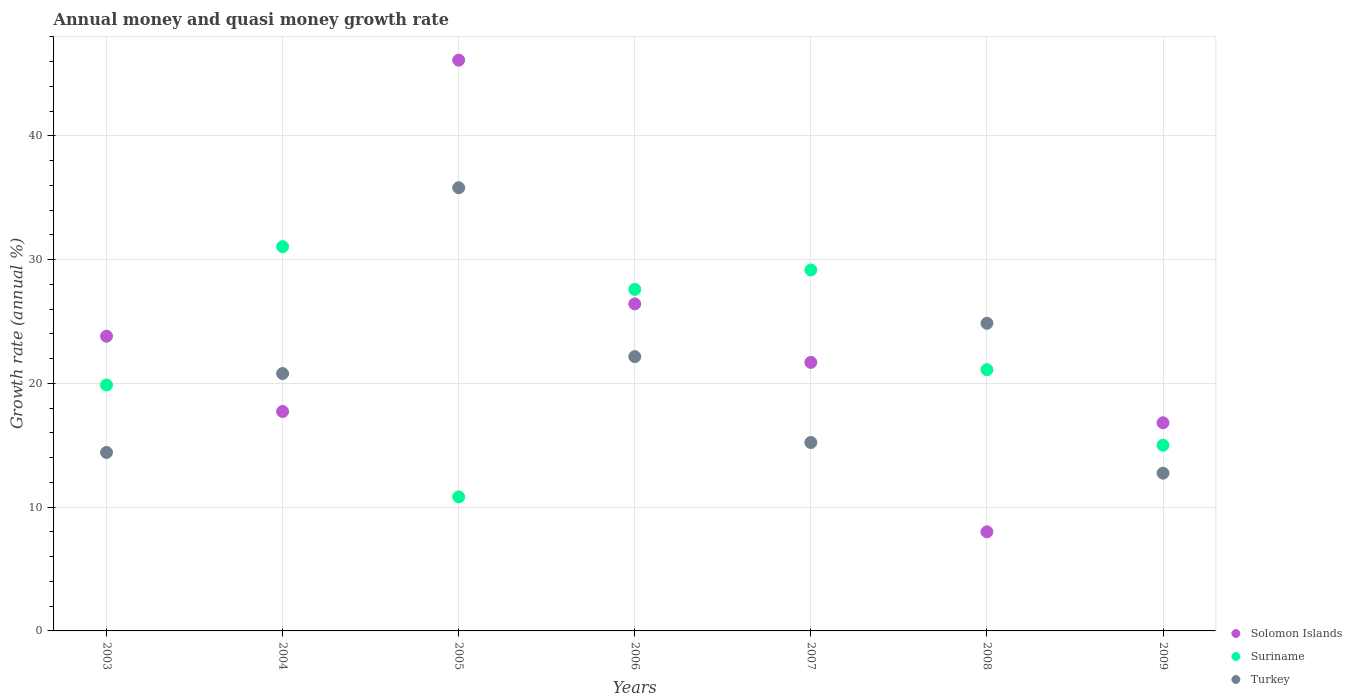How many different coloured dotlines are there?
Provide a succinct answer. 3. Is the number of dotlines equal to the number of legend labels?
Make the answer very short. Yes. What is the growth rate in Turkey in 2004?
Give a very brief answer. 20.8. Across all years, what is the maximum growth rate in Solomon Islands?
Offer a very short reply. 46.12. Across all years, what is the minimum growth rate in Turkey?
Provide a short and direct response. 12.75. In which year was the growth rate in Turkey maximum?
Give a very brief answer. 2005. In which year was the growth rate in Suriname minimum?
Your response must be concise. 2005. What is the total growth rate in Solomon Islands in the graph?
Your response must be concise. 160.61. What is the difference between the growth rate in Solomon Islands in 2006 and that in 2009?
Offer a terse response. 9.6. What is the difference between the growth rate in Solomon Islands in 2006 and the growth rate in Turkey in 2007?
Your answer should be compact. 11.2. What is the average growth rate in Solomon Islands per year?
Offer a very short reply. 22.94. In the year 2007, what is the difference between the growth rate in Suriname and growth rate in Solomon Islands?
Your response must be concise. 7.47. What is the ratio of the growth rate in Turkey in 2004 to that in 2008?
Provide a short and direct response. 0.84. Is the growth rate in Turkey in 2004 less than that in 2008?
Provide a short and direct response. Yes. What is the difference between the highest and the second highest growth rate in Suriname?
Make the answer very short. 1.89. What is the difference between the highest and the lowest growth rate in Solomon Islands?
Your answer should be compact. 38.11. Does the growth rate in Turkey monotonically increase over the years?
Your answer should be compact. No. Is the growth rate in Suriname strictly greater than the growth rate in Turkey over the years?
Offer a terse response. No. Is the growth rate in Solomon Islands strictly less than the growth rate in Turkey over the years?
Your answer should be compact. No. Are the values on the major ticks of Y-axis written in scientific E-notation?
Your response must be concise. No. Does the graph contain any zero values?
Your response must be concise. No. How many legend labels are there?
Your response must be concise. 3. How are the legend labels stacked?
Offer a very short reply. Vertical. What is the title of the graph?
Your response must be concise. Annual money and quasi money growth rate. What is the label or title of the Y-axis?
Your response must be concise. Growth rate (annual %). What is the Growth rate (annual %) of Solomon Islands in 2003?
Your answer should be very brief. 23.82. What is the Growth rate (annual %) of Suriname in 2003?
Make the answer very short. 19.87. What is the Growth rate (annual %) in Turkey in 2003?
Ensure brevity in your answer.  14.42. What is the Growth rate (annual %) of Solomon Islands in 2004?
Make the answer very short. 17.73. What is the Growth rate (annual %) in Suriname in 2004?
Give a very brief answer. 31.05. What is the Growth rate (annual %) in Turkey in 2004?
Your response must be concise. 20.8. What is the Growth rate (annual %) of Solomon Islands in 2005?
Keep it short and to the point. 46.12. What is the Growth rate (annual %) of Suriname in 2005?
Offer a very short reply. 10.83. What is the Growth rate (annual %) of Turkey in 2005?
Your answer should be compact. 35.81. What is the Growth rate (annual %) of Solomon Islands in 2006?
Your response must be concise. 26.42. What is the Growth rate (annual %) of Suriname in 2006?
Provide a succinct answer. 27.6. What is the Growth rate (annual %) in Turkey in 2006?
Give a very brief answer. 22.16. What is the Growth rate (annual %) of Solomon Islands in 2007?
Ensure brevity in your answer.  21.7. What is the Growth rate (annual %) in Suriname in 2007?
Give a very brief answer. 29.17. What is the Growth rate (annual %) in Turkey in 2007?
Provide a short and direct response. 15.23. What is the Growth rate (annual %) of Solomon Islands in 2008?
Ensure brevity in your answer.  8.01. What is the Growth rate (annual %) of Suriname in 2008?
Offer a terse response. 21.11. What is the Growth rate (annual %) in Turkey in 2008?
Offer a terse response. 24.86. What is the Growth rate (annual %) of Solomon Islands in 2009?
Your answer should be very brief. 16.82. What is the Growth rate (annual %) of Suriname in 2009?
Ensure brevity in your answer.  15. What is the Growth rate (annual %) in Turkey in 2009?
Provide a succinct answer. 12.75. Across all years, what is the maximum Growth rate (annual %) of Solomon Islands?
Your answer should be very brief. 46.12. Across all years, what is the maximum Growth rate (annual %) of Suriname?
Your answer should be compact. 31.05. Across all years, what is the maximum Growth rate (annual %) in Turkey?
Offer a very short reply. 35.81. Across all years, what is the minimum Growth rate (annual %) of Solomon Islands?
Your answer should be very brief. 8.01. Across all years, what is the minimum Growth rate (annual %) of Suriname?
Keep it short and to the point. 10.83. Across all years, what is the minimum Growth rate (annual %) in Turkey?
Offer a very short reply. 12.75. What is the total Growth rate (annual %) in Solomon Islands in the graph?
Make the answer very short. 160.61. What is the total Growth rate (annual %) in Suriname in the graph?
Provide a short and direct response. 154.63. What is the total Growth rate (annual %) of Turkey in the graph?
Provide a short and direct response. 146.02. What is the difference between the Growth rate (annual %) of Solomon Islands in 2003 and that in 2004?
Your response must be concise. 6.09. What is the difference between the Growth rate (annual %) of Suriname in 2003 and that in 2004?
Offer a terse response. -11.18. What is the difference between the Growth rate (annual %) in Turkey in 2003 and that in 2004?
Offer a terse response. -6.38. What is the difference between the Growth rate (annual %) of Solomon Islands in 2003 and that in 2005?
Ensure brevity in your answer.  -22.3. What is the difference between the Growth rate (annual %) in Suriname in 2003 and that in 2005?
Offer a terse response. 9.04. What is the difference between the Growth rate (annual %) in Turkey in 2003 and that in 2005?
Keep it short and to the point. -21.39. What is the difference between the Growth rate (annual %) of Solomon Islands in 2003 and that in 2006?
Ensure brevity in your answer.  -2.61. What is the difference between the Growth rate (annual %) of Suriname in 2003 and that in 2006?
Provide a succinct answer. -7.73. What is the difference between the Growth rate (annual %) in Turkey in 2003 and that in 2006?
Your answer should be very brief. -7.74. What is the difference between the Growth rate (annual %) of Solomon Islands in 2003 and that in 2007?
Provide a succinct answer. 2.12. What is the difference between the Growth rate (annual %) of Suriname in 2003 and that in 2007?
Make the answer very short. -9.3. What is the difference between the Growth rate (annual %) in Turkey in 2003 and that in 2007?
Provide a short and direct response. -0.81. What is the difference between the Growth rate (annual %) in Solomon Islands in 2003 and that in 2008?
Provide a succinct answer. 15.81. What is the difference between the Growth rate (annual %) of Suriname in 2003 and that in 2008?
Make the answer very short. -1.24. What is the difference between the Growth rate (annual %) of Turkey in 2003 and that in 2008?
Your answer should be compact. -10.44. What is the difference between the Growth rate (annual %) of Solomon Islands in 2003 and that in 2009?
Keep it short and to the point. 7. What is the difference between the Growth rate (annual %) of Suriname in 2003 and that in 2009?
Keep it short and to the point. 4.87. What is the difference between the Growth rate (annual %) in Turkey in 2003 and that in 2009?
Ensure brevity in your answer.  1.67. What is the difference between the Growth rate (annual %) in Solomon Islands in 2004 and that in 2005?
Offer a terse response. -28.39. What is the difference between the Growth rate (annual %) in Suriname in 2004 and that in 2005?
Keep it short and to the point. 20.22. What is the difference between the Growth rate (annual %) in Turkey in 2004 and that in 2005?
Offer a very short reply. -15.01. What is the difference between the Growth rate (annual %) in Solomon Islands in 2004 and that in 2006?
Offer a very short reply. -8.69. What is the difference between the Growth rate (annual %) of Suriname in 2004 and that in 2006?
Provide a short and direct response. 3.46. What is the difference between the Growth rate (annual %) in Turkey in 2004 and that in 2006?
Offer a very short reply. -1.37. What is the difference between the Growth rate (annual %) in Solomon Islands in 2004 and that in 2007?
Make the answer very short. -3.97. What is the difference between the Growth rate (annual %) in Suriname in 2004 and that in 2007?
Provide a succinct answer. 1.89. What is the difference between the Growth rate (annual %) of Turkey in 2004 and that in 2007?
Your answer should be compact. 5.57. What is the difference between the Growth rate (annual %) of Solomon Islands in 2004 and that in 2008?
Offer a terse response. 9.72. What is the difference between the Growth rate (annual %) of Suriname in 2004 and that in 2008?
Ensure brevity in your answer.  9.95. What is the difference between the Growth rate (annual %) in Turkey in 2004 and that in 2008?
Offer a terse response. -4.06. What is the difference between the Growth rate (annual %) in Solomon Islands in 2004 and that in 2009?
Keep it short and to the point. 0.91. What is the difference between the Growth rate (annual %) of Suriname in 2004 and that in 2009?
Give a very brief answer. 16.05. What is the difference between the Growth rate (annual %) in Turkey in 2004 and that in 2009?
Make the answer very short. 8.05. What is the difference between the Growth rate (annual %) in Solomon Islands in 2005 and that in 2006?
Offer a terse response. 19.69. What is the difference between the Growth rate (annual %) of Suriname in 2005 and that in 2006?
Your response must be concise. -16.76. What is the difference between the Growth rate (annual %) of Turkey in 2005 and that in 2006?
Offer a very short reply. 13.65. What is the difference between the Growth rate (annual %) in Solomon Islands in 2005 and that in 2007?
Offer a terse response. 24.42. What is the difference between the Growth rate (annual %) in Suriname in 2005 and that in 2007?
Offer a terse response. -18.34. What is the difference between the Growth rate (annual %) of Turkey in 2005 and that in 2007?
Offer a terse response. 20.58. What is the difference between the Growth rate (annual %) of Solomon Islands in 2005 and that in 2008?
Your answer should be compact. 38.11. What is the difference between the Growth rate (annual %) of Suriname in 2005 and that in 2008?
Give a very brief answer. -10.28. What is the difference between the Growth rate (annual %) of Turkey in 2005 and that in 2008?
Your answer should be compact. 10.95. What is the difference between the Growth rate (annual %) of Solomon Islands in 2005 and that in 2009?
Ensure brevity in your answer.  29.3. What is the difference between the Growth rate (annual %) in Suriname in 2005 and that in 2009?
Ensure brevity in your answer.  -4.17. What is the difference between the Growth rate (annual %) in Turkey in 2005 and that in 2009?
Make the answer very short. 23.06. What is the difference between the Growth rate (annual %) of Solomon Islands in 2006 and that in 2007?
Make the answer very short. 4.72. What is the difference between the Growth rate (annual %) of Suriname in 2006 and that in 2007?
Your response must be concise. -1.57. What is the difference between the Growth rate (annual %) in Turkey in 2006 and that in 2007?
Provide a succinct answer. 6.94. What is the difference between the Growth rate (annual %) of Solomon Islands in 2006 and that in 2008?
Offer a terse response. 18.42. What is the difference between the Growth rate (annual %) in Suriname in 2006 and that in 2008?
Your response must be concise. 6.49. What is the difference between the Growth rate (annual %) of Turkey in 2006 and that in 2008?
Your answer should be very brief. -2.69. What is the difference between the Growth rate (annual %) in Solomon Islands in 2006 and that in 2009?
Your answer should be compact. 9.6. What is the difference between the Growth rate (annual %) in Suriname in 2006 and that in 2009?
Your answer should be very brief. 12.59. What is the difference between the Growth rate (annual %) in Turkey in 2006 and that in 2009?
Give a very brief answer. 9.42. What is the difference between the Growth rate (annual %) of Solomon Islands in 2007 and that in 2008?
Make the answer very short. 13.7. What is the difference between the Growth rate (annual %) of Suriname in 2007 and that in 2008?
Your answer should be very brief. 8.06. What is the difference between the Growth rate (annual %) of Turkey in 2007 and that in 2008?
Your answer should be very brief. -9.63. What is the difference between the Growth rate (annual %) in Solomon Islands in 2007 and that in 2009?
Your response must be concise. 4.88. What is the difference between the Growth rate (annual %) in Suriname in 2007 and that in 2009?
Ensure brevity in your answer.  14.16. What is the difference between the Growth rate (annual %) of Turkey in 2007 and that in 2009?
Offer a very short reply. 2.48. What is the difference between the Growth rate (annual %) of Solomon Islands in 2008 and that in 2009?
Provide a short and direct response. -8.81. What is the difference between the Growth rate (annual %) in Suriname in 2008 and that in 2009?
Your answer should be very brief. 6.1. What is the difference between the Growth rate (annual %) in Turkey in 2008 and that in 2009?
Ensure brevity in your answer.  12.11. What is the difference between the Growth rate (annual %) in Solomon Islands in 2003 and the Growth rate (annual %) in Suriname in 2004?
Offer a very short reply. -7.24. What is the difference between the Growth rate (annual %) of Solomon Islands in 2003 and the Growth rate (annual %) of Turkey in 2004?
Offer a terse response. 3.02. What is the difference between the Growth rate (annual %) of Suriname in 2003 and the Growth rate (annual %) of Turkey in 2004?
Your answer should be compact. -0.92. What is the difference between the Growth rate (annual %) in Solomon Islands in 2003 and the Growth rate (annual %) in Suriname in 2005?
Keep it short and to the point. 12.98. What is the difference between the Growth rate (annual %) in Solomon Islands in 2003 and the Growth rate (annual %) in Turkey in 2005?
Provide a succinct answer. -11.99. What is the difference between the Growth rate (annual %) of Suriname in 2003 and the Growth rate (annual %) of Turkey in 2005?
Provide a short and direct response. -15.94. What is the difference between the Growth rate (annual %) of Solomon Islands in 2003 and the Growth rate (annual %) of Suriname in 2006?
Your response must be concise. -3.78. What is the difference between the Growth rate (annual %) of Solomon Islands in 2003 and the Growth rate (annual %) of Turkey in 2006?
Keep it short and to the point. 1.65. What is the difference between the Growth rate (annual %) of Suriname in 2003 and the Growth rate (annual %) of Turkey in 2006?
Offer a terse response. -2.29. What is the difference between the Growth rate (annual %) in Solomon Islands in 2003 and the Growth rate (annual %) in Suriname in 2007?
Provide a short and direct response. -5.35. What is the difference between the Growth rate (annual %) of Solomon Islands in 2003 and the Growth rate (annual %) of Turkey in 2007?
Give a very brief answer. 8.59. What is the difference between the Growth rate (annual %) of Suriname in 2003 and the Growth rate (annual %) of Turkey in 2007?
Give a very brief answer. 4.65. What is the difference between the Growth rate (annual %) of Solomon Islands in 2003 and the Growth rate (annual %) of Suriname in 2008?
Give a very brief answer. 2.71. What is the difference between the Growth rate (annual %) in Solomon Islands in 2003 and the Growth rate (annual %) in Turkey in 2008?
Give a very brief answer. -1.04. What is the difference between the Growth rate (annual %) of Suriname in 2003 and the Growth rate (annual %) of Turkey in 2008?
Provide a short and direct response. -4.99. What is the difference between the Growth rate (annual %) in Solomon Islands in 2003 and the Growth rate (annual %) in Suriname in 2009?
Make the answer very short. 8.81. What is the difference between the Growth rate (annual %) of Solomon Islands in 2003 and the Growth rate (annual %) of Turkey in 2009?
Your answer should be very brief. 11.07. What is the difference between the Growth rate (annual %) in Suriname in 2003 and the Growth rate (annual %) in Turkey in 2009?
Offer a very short reply. 7.12. What is the difference between the Growth rate (annual %) in Solomon Islands in 2004 and the Growth rate (annual %) in Suriname in 2005?
Offer a terse response. 6.9. What is the difference between the Growth rate (annual %) in Solomon Islands in 2004 and the Growth rate (annual %) in Turkey in 2005?
Offer a very short reply. -18.08. What is the difference between the Growth rate (annual %) of Suriname in 2004 and the Growth rate (annual %) of Turkey in 2005?
Offer a terse response. -4.76. What is the difference between the Growth rate (annual %) of Solomon Islands in 2004 and the Growth rate (annual %) of Suriname in 2006?
Provide a succinct answer. -9.87. What is the difference between the Growth rate (annual %) of Solomon Islands in 2004 and the Growth rate (annual %) of Turkey in 2006?
Offer a very short reply. -4.43. What is the difference between the Growth rate (annual %) of Suriname in 2004 and the Growth rate (annual %) of Turkey in 2006?
Your answer should be compact. 8.89. What is the difference between the Growth rate (annual %) of Solomon Islands in 2004 and the Growth rate (annual %) of Suriname in 2007?
Provide a succinct answer. -11.44. What is the difference between the Growth rate (annual %) of Solomon Islands in 2004 and the Growth rate (annual %) of Turkey in 2007?
Your answer should be very brief. 2.5. What is the difference between the Growth rate (annual %) of Suriname in 2004 and the Growth rate (annual %) of Turkey in 2007?
Ensure brevity in your answer.  15.83. What is the difference between the Growth rate (annual %) in Solomon Islands in 2004 and the Growth rate (annual %) in Suriname in 2008?
Your answer should be very brief. -3.38. What is the difference between the Growth rate (annual %) in Solomon Islands in 2004 and the Growth rate (annual %) in Turkey in 2008?
Give a very brief answer. -7.13. What is the difference between the Growth rate (annual %) in Suriname in 2004 and the Growth rate (annual %) in Turkey in 2008?
Your answer should be very brief. 6.2. What is the difference between the Growth rate (annual %) of Solomon Islands in 2004 and the Growth rate (annual %) of Suriname in 2009?
Give a very brief answer. 2.73. What is the difference between the Growth rate (annual %) of Solomon Islands in 2004 and the Growth rate (annual %) of Turkey in 2009?
Your answer should be very brief. 4.98. What is the difference between the Growth rate (annual %) of Suriname in 2004 and the Growth rate (annual %) of Turkey in 2009?
Make the answer very short. 18.31. What is the difference between the Growth rate (annual %) of Solomon Islands in 2005 and the Growth rate (annual %) of Suriname in 2006?
Provide a short and direct response. 18.52. What is the difference between the Growth rate (annual %) of Solomon Islands in 2005 and the Growth rate (annual %) of Turkey in 2006?
Provide a short and direct response. 23.96. What is the difference between the Growth rate (annual %) of Suriname in 2005 and the Growth rate (annual %) of Turkey in 2006?
Ensure brevity in your answer.  -11.33. What is the difference between the Growth rate (annual %) of Solomon Islands in 2005 and the Growth rate (annual %) of Suriname in 2007?
Offer a very short reply. 16.95. What is the difference between the Growth rate (annual %) in Solomon Islands in 2005 and the Growth rate (annual %) in Turkey in 2007?
Give a very brief answer. 30.89. What is the difference between the Growth rate (annual %) of Suriname in 2005 and the Growth rate (annual %) of Turkey in 2007?
Make the answer very short. -4.39. What is the difference between the Growth rate (annual %) in Solomon Islands in 2005 and the Growth rate (annual %) in Suriname in 2008?
Offer a terse response. 25.01. What is the difference between the Growth rate (annual %) of Solomon Islands in 2005 and the Growth rate (annual %) of Turkey in 2008?
Give a very brief answer. 21.26. What is the difference between the Growth rate (annual %) of Suriname in 2005 and the Growth rate (annual %) of Turkey in 2008?
Make the answer very short. -14.03. What is the difference between the Growth rate (annual %) of Solomon Islands in 2005 and the Growth rate (annual %) of Suriname in 2009?
Make the answer very short. 31.12. What is the difference between the Growth rate (annual %) in Solomon Islands in 2005 and the Growth rate (annual %) in Turkey in 2009?
Offer a very short reply. 33.37. What is the difference between the Growth rate (annual %) in Suriname in 2005 and the Growth rate (annual %) in Turkey in 2009?
Give a very brief answer. -1.91. What is the difference between the Growth rate (annual %) of Solomon Islands in 2006 and the Growth rate (annual %) of Suriname in 2007?
Your answer should be compact. -2.74. What is the difference between the Growth rate (annual %) in Solomon Islands in 2006 and the Growth rate (annual %) in Turkey in 2007?
Ensure brevity in your answer.  11.2. What is the difference between the Growth rate (annual %) of Suriname in 2006 and the Growth rate (annual %) of Turkey in 2007?
Your answer should be compact. 12.37. What is the difference between the Growth rate (annual %) of Solomon Islands in 2006 and the Growth rate (annual %) of Suriname in 2008?
Keep it short and to the point. 5.32. What is the difference between the Growth rate (annual %) of Solomon Islands in 2006 and the Growth rate (annual %) of Turkey in 2008?
Provide a succinct answer. 1.57. What is the difference between the Growth rate (annual %) of Suriname in 2006 and the Growth rate (annual %) of Turkey in 2008?
Your response must be concise. 2.74. What is the difference between the Growth rate (annual %) in Solomon Islands in 2006 and the Growth rate (annual %) in Suriname in 2009?
Offer a very short reply. 11.42. What is the difference between the Growth rate (annual %) in Solomon Islands in 2006 and the Growth rate (annual %) in Turkey in 2009?
Provide a short and direct response. 13.68. What is the difference between the Growth rate (annual %) in Suriname in 2006 and the Growth rate (annual %) in Turkey in 2009?
Make the answer very short. 14.85. What is the difference between the Growth rate (annual %) in Solomon Islands in 2007 and the Growth rate (annual %) in Suriname in 2008?
Offer a terse response. 0.59. What is the difference between the Growth rate (annual %) in Solomon Islands in 2007 and the Growth rate (annual %) in Turkey in 2008?
Provide a short and direct response. -3.16. What is the difference between the Growth rate (annual %) in Suriname in 2007 and the Growth rate (annual %) in Turkey in 2008?
Your response must be concise. 4.31. What is the difference between the Growth rate (annual %) in Solomon Islands in 2007 and the Growth rate (annual %) in Suriname in 2009?
Your answer should be very brief. 6.7. What is the difference between the Growth rate (annual %) in Solomon Islands in 2007 and the Growth rate (annual %) in Turkey in 2009?
Keep it short and to the point. 8.95. What is the difference between the Growth rate (annual %) of Suriname in 2007 and the Growth rate (annual %) of Turkey in 2009?
Give a very brief answer. 16.42. What is the difference between the Growth rate (annual %) in Solomon Islands in 2008 and the Growth rate (annual %) in Suriname in 2009?
Give a very brief answer. -7. What is the difference between the Growth rate (annual %) in Solomon Islands in 2008 and the Growth rate (annual %) in Turkey in 2009?
Offer a terse response. -4.74. What is the difference between the Growth rate (annual %) of Suriname in 2008 and the Growth rate (annual %) of Turkey in 2009?
Provide a short and direct response. 8.36. What is the average Growth rate (annual %) in Solomon Islands per year?
Provide a short and direct response. 22.94. What is the average Growth rate (annual %) of Suriname per year?
Your answer should be compact. 22.09. What is the average Growth rate (annual %) of Turkey per year?
Your response must be concise. 20.86. In the year 2003, what is the difference between the Growth rate (annual %) in Solomon Islands and Growth rate (annual %) in Suriname?
Offer a terse response. 3.94. In the year 2003, what is the difference between the Growth rate (annual %) in Solomon Islands and Growth rate (annual %) in Turkey?
Give a very brief answer. 9.4. In the year 2003, what is the difference between the Growth rate (annual %) of Suriname and Growth rate (annual %) of Turkey?
Your response must be concise. 5.45. In the year 2004, what is the difference between the Growth rate (annual %) of Solomon Islands and Growth rate (annual %) of Suriname?
Provide a succinct answer. -13.32. In the year 2004, what is the difference between the Growth rate (annual %) of Solomon Islands and Growth rate (annual %) of Turkey?
Your answer should be very brief. -3.07. In the year 2004, what is the difference between the Growth rate (annual %) in Suriname and Growth rate (annual %) in Turkey?
Provide a short and direct response. 10.26. In the year 2005, what is the difference between the Growth rate (annual %) in Solomon Islands and Growth rate (annual %) in Suriname?
Keep it short and to the point. 35.29. In the year 2005, what is the difference between the Growth rate (annual %) of Solomon Islands and Growth rate (annual %) of Turkey?
Make the answer very short. 10.31. In the year 2005, what is the difference between the Growth rate (annual %) of Suriname and Growth rate (annual %) of Turkey?
Make the answer very short. -24.98. In the year 2006, what is the difference between the Growth rate (annual %) in Solomon Islands and Growth rate (annual %) in Suriname?
Keep it short and to the point. -1.17. In the year 2006, what is the difference between the Growth rate (annual %) of Solomon Islands and Growth rate (annual %) of Turkey?
Ensure brevity in your answer.  4.26. In the year 2006, what is the difference between the Growth rate (annual %) of Suriname and Growth rate (annual %) of Turkey?
Offer a very short reply. 5.43. In the year 2007, what is the difference between the Growth rate (annual %) of Solomon Islands and Growth rate (annual %) of Suriname?
Your answer should be compact. -7.47. In the year 2007, what is the difference between the Growth rate (annual %) of Solomon Islands and Growth rate (annual %) of Turkey?
Provide a succinct answer. 6.47. In the year 2007, what is the difference between the Growth rate (annual %) in Suriname and Growth rate (annual %) in Turkey?
Keep it short and to the point. 13.94. In the year 2008, what is the difference between the Growth rate (annual %) of Solomon Islands and Growth rate (annual %) of Suriname?
Keep it short and to the point. -13.1. In the year 2008, what is the difference between the Growth rate (annual %) of Solomon Islands and Growth rate (annual %) of Turkey?
Make the answer very short. -16.85. In the year 2008, what is the difference between the Growth rate (annual %) in Suriname and Growth rate (annual %) in Turkey?
Ensure brevity in your answer.  -3.75. In the year 2009, what is the difference between the Growth rate (annual %) of Solomon Islands and Growth rate (annual %) of Suriname?
Ensure brevity in your answer.  1.82. In the year 2009, what is the difference between the Growth rate (annual %) in Solomon Islands and Growth rate (annual %) in Turkey?
Give a very brief answer. 4.07. In the year 2009, what is the difference between the Growth rate (annual %) of Suriname and Growth rate (annual %) of Turkey?
Your response must be concise. 2.26. What is the ratio of the Growth rate (annual %) of Solomon Islands in 2003 to that in 2004?
Keep it short and to the point. 1.34. What is the ratio of the Growth rate (annual %) of Suriname in 2003 to that in 2004?
Your answer should be compact. 0.64. What is the ratio of the Growth rate (annual %) of Turkey in 2003 to that in 2004?
Give a very brief answer. 0.69. What is the ratio of the Growth rate (annual %) in Solomon Islands in 2003 to that in 2005?
Ensure brevity in your answer.  0.52. What is the ratio of the Growth rate (annual %) of Suriname in 2003 to that in 2005?
Your response must be concise. 1.83. What is the ratio of the Growth rate (annual %) of Turkey in 2003 to that in 2005?
Your response must be concise. 0.4. What is the ratio of the Growth rate (annual %) in Solomon Islands in 2003 to that in 2006?
Your answer should be very brief. 0.9. What is the ratio of the Growth rate (annual %) of Suriname in 2003 to that in 2006?
Provide a succinct answer. 0.72. What is the ratio of the Growth rate (annual %) in Turkey in 2003 to that in 2006?
Your response must be concise. 0.65. What is the ratio of the Growth rate (annual %) in Solomon Islands in 2003 to that in 2007?
Keep it short and to the point. 1.1. What is the ratio of the Growth rate (annual %) of Suriname in 2003 to that in 2007?
Give a very brief answer. 0.68. What is the ratio of the Growth rate (annual %) of Turkey in 2003 to that in 2007?
Provide a succinct answer. 0.95. What is the ratio of the Growth rate (annual %) of Solomon Islands in 2003 to that in 2008?
Give a very brief answer. 2.98. What is the ratio of the Growth rate (annual %) of Suriname in 2003 to that in 2008?
Make the answer very short. 0.94. What is the ratio of the Growth rate (annual %) of Turkey in 2003 to that in 2008?
Keep it short and to the point. 0.58. What is the ratio of the Growth rate (annual %) in Solomon Islands in 2003 to that in 2009?
Provide a succinct answer. 1.42. What is the ratio of the Growth rate (annual %) of Suriname in 2003 to that in 2009?
Give a very brief answer. 1.32. What is the ratio of the Growth rate (annual %) of Turkey in 2003 to that in 2009?
Keep it short and to the point. 1.13. What is the ratio of the Growth rate (annual %) of Solomon Islands in 2004 to that in 2005?
Keep it short and to the point. 0.38. What is the ratio of the Growth rate (annual %) of Suriname in 2004 to that in 2005?
Your answer should be very brief. 2.87. What is the ratio of the Growth rate (annual %) in Turkey in 2004 to that in 2005?
Your answer should be compact. 0.58. What is the ratio of the Growth rate (annual %) in Solomon Islands in 2004 to that in 2006?
Your answer should be very brief. 0.67. What is the ratio of the Growth rate (annual %) in Suriname in 2004 to that in 2006?
Offer a very short reply. 1.13. What is the ratio of the Growth rate (annual %) in Turkey in 2004 to that in 2006?
Give a very brief answer. 0.94. What is the ratio of the Growth rate (annual %) in Solomon Islands in 2004 to that in 2007?
Provide a succinct answer. 0.82. What is the ratio of the Growth rate (annual %) of Suriname in 2004 to that in 2007?
Give a very brief answer. 1.06. What is the ratio of the Growth rate (annual %) of Turkey in 2004 to that in 2007?
Make the answer very short. 1.37. What is the ratio of the Growth rate (annual %) of Solomon Islands in 2004 to that in 2008?
Offer a terse response. 2.21. What is the ratio of the Growth rate (annual %) in Suriname in 2004 to that in 2008?
Offer a very short reply. 1.47. What is the ratio of the Growth rate (annual %) in Turkey in 2004 to that in 2008?
Your answer should be compact. 0.84. What is the ratio of the Growth rate (annual %) in Solomon Islands in 2004 to that in 2009?
Keep it short and to the point. 1.05. What is the ratio of the Growth rate (annual %) of Suriname in 2004 to that in 2009?
Give a very brief answer. 2.07. What is the ratio of the Growth rate (annual %) of Turkey in 2004 to that in 2009?
Your response must be concise. 1.63. What is the ratio of the Growth rate (annual %) in Solomon Islands in 2005 to that in 2006?
Your answer should be very brief. 1.75. What is the ratio of the Growth rate (annual %) of Suriname in 2005 to that in 2006?
Your answer should be compact. 0.39. What is the ratio of the Growth rate (annual %) of Turkey in 2005 to that in 2006?
Your answer should be compact. 1.62. What is the ratio of the Growth rate (annual %) in Solomon Islands in 2005 to that in 2007?
Give a very brief answer. 2.13. What is the ratio of the Growth rate (annual %) of Suriname in 2005 to that in 2007?
Offer a very short reply. 0.37. What is the ratio of the Growth rate (annual %) of Turkey in 2005 to that in 2007?
Your response must be concise. 2.35. What is the ratio of the Growth rate (annual %) in Solomon Islands in 2005 to that in 2008?
Make the answer very short. 5.76. What is the ratio of the Growth rate (annual %) of Suriname in 2005 to that in 2008?
Make the answer very short. 0.51. What is the ratio of the Growth rate (annual %) in Turkey in 2005 to that in 2008?
Offer a very short reply. 1.44. What is the ratio of the Growth rate (annual %) in Solomon Islands in 2005 to that in 2009?
Your response must be concise. 2.74. What is the ratio of the Growth rate (annual %) in Suriname in 2005 to that in 2009?
Your answer should be very brief. 0.72. What is the ratio of the Growth rate (annual %) of Turkey in 2005 to that in 2009?
Provide a succinct answer. 2.81. What is the ratio of the Growth rate (annual %) of Solomon Islands in 2006 to that in 2007?
Your response must be concise. 1.22. What is the ratio of the Growth rate (annual %) in Suriname in 2006 to that in 2007?
Keep it short and to the point. 0.95. What is the ratio of the Growth rate (annual %) of Turkey in 2006 to that in 2007?
Offer a very short reply. 1.46. What is the ratio of the Growth rate (annual %) of Solomon Islands in 2006 to that in 2008?
Give a very brief answer. 3.3. What is the ratio of the Growth rate (annual %) in Suriname in 2006 to that in 2008?
Offer a terse response. 1.31. What is the ratio of the Growth rate (annual %) in Turkey in 2006 to that in 2008?
Ensure brevity in your answer.  0.89. What is the ratio of the Growth rate (annual %) of Solomon Islands in 2006 to that in 2009?
Provide a succinct answer. 1.57. What is the ratio of the Growth rate (annual %) of Suriname in 2006 to that in 2009?
Give a very brief answer. 1.84. What is the ratio of the Growth rate (annual %) of Turkey in 2006 to that in 2009?
Ensure brevity in your answer.  1.74. What is the ratio of the Growth rate (annual %) of Solomon Islands in 2007 to that in 2008?
Provide a succinct answer. 2.71. What is the ratio of the Growth rate (annual %) of Suriname in 2007 to that in 2008?
Ensure brevity in your answer.  1.38. What is the ratio of the Growth rate (annual %) in Turkey in 2007 to that in 2008?
Offer a very short reply. 0.61. What is the ratio of the Growth rate (annual %) of Solomon Islands in 2007 to that in 2009?
Provide a short and direct response. 1.29. What is the ratio of the Growth rate (annual %) of Suriname in 2007 to that in 2009?
Your answer should be very brief. 1.94. What is the ratio of the Growth rate (annual %) of Turkey in 2007 to that in 2009?
Provide a succinct answer. 1.19. What is the ratio of the Growth rate (annual %) in Solomon Islands in 2008 to that in 2009?
Offer a terse response. 0.48. What is the ratio of the Growth rate (annual %) of Suriname in 2008 to that in 2009?
Offer a terse response. 1.41. What is the ratio of the Growth rate (annual %) of Turkey in 2008 to that in 2009?
Your answer should be compact. 1.95. What is the difference between the highest and the second highest Growth rate (annual %) of Solomon Islands?
Your response must be concise. 19.69. What is the difference between the highest and the second highest Growth rate (annual %) in Suriname?
Offer a terse response. 1.89. What is the difference between the highest and the second highest Growth rate (annual %) of Turkey?
Provide a succinct answer. 10.95. What is the difference between the highest and the lowest Growth rate (annual %) in Solomon Islands?
Provide a succinct answer. 38.11. What is the difference between the highest and the lowest Growth rate (annual %) of Suriname?
Provide a succinct answer. 20.22. What is the difference between the highest and the lowest Growth rate (annual %) in Turkey?
Give a very brief answer. 23.06. 